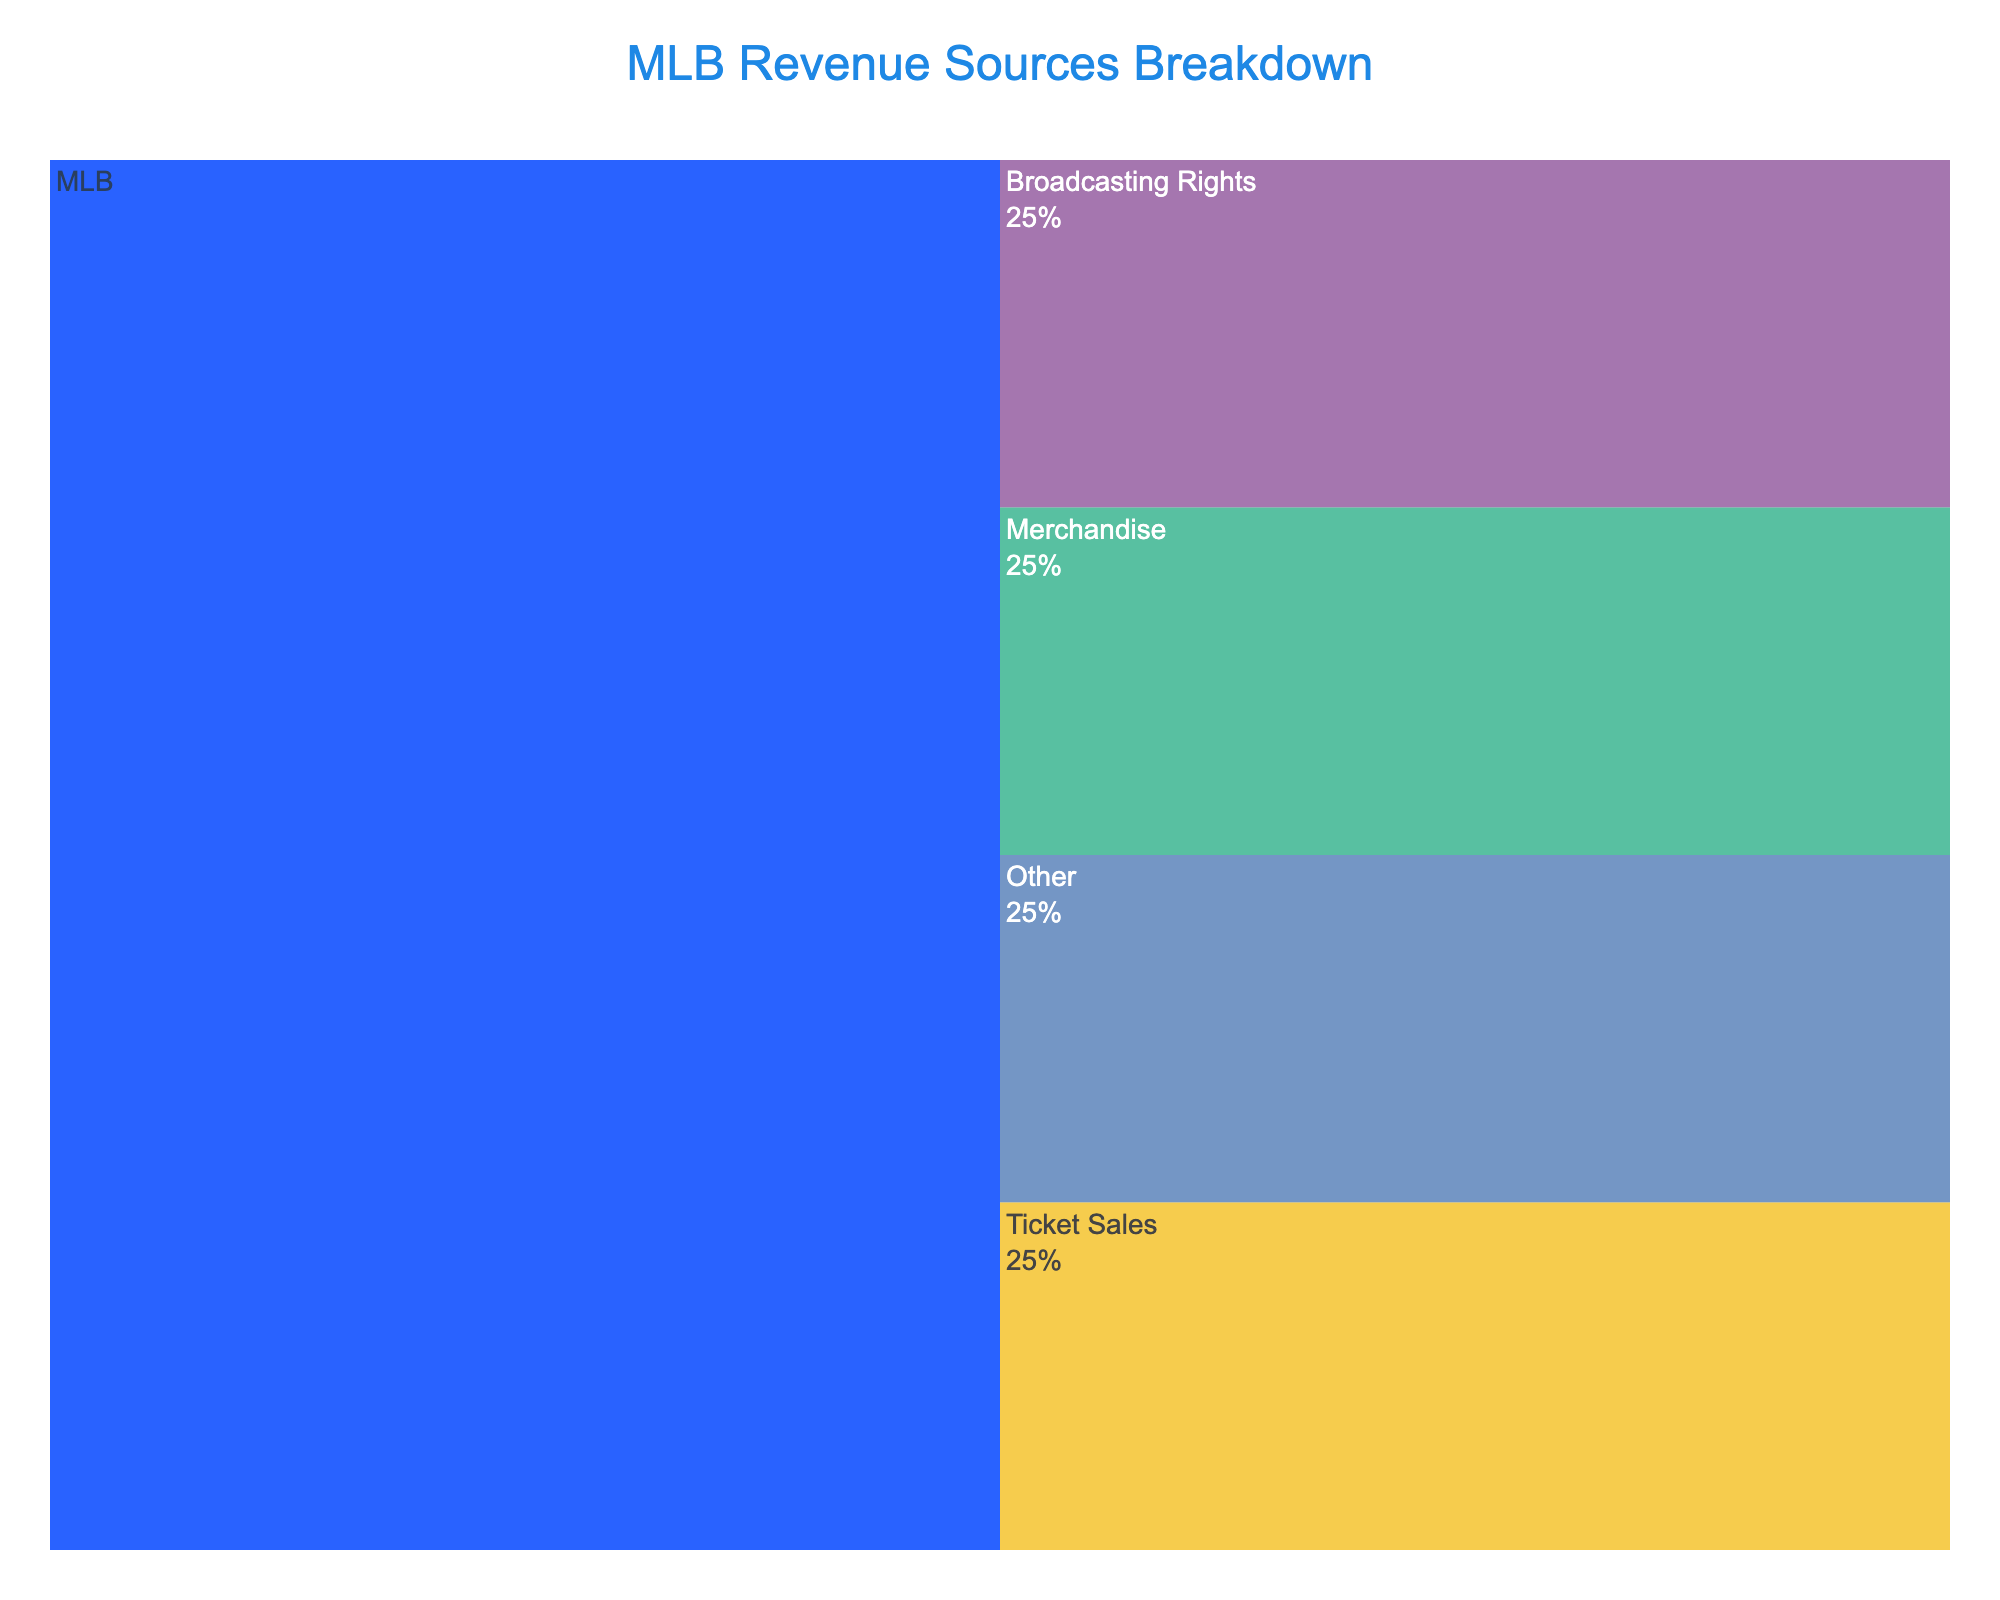What is the title of the Icicle Chart? The title is located at the top of the figure and provides a concise summary of the chart's content. "MLB Revenue Sources Breakdown" is clearly displayed in the title section.
Answer: MLB Revenue Sources Breakdown Which color is used for the root (MLB) level in the chart? The root color is prominently displayed and differentiates the main level from the subordinate ones. The root level (MLB) is shown in a distinct dark blue color.
Answer: Dark blue How many revenue sources are displayed in the chart? The chart breaks down MLB revenue into its components, each represented by a segment. By visually counting these segments at the "Revenue Sources" level, you can determine the total number of revenue sources.
Answer: 4 What percentage of the parent category does "Ticket Sales" represent? The chart includes percentage labels for each segment relative to their parent category. "Ticket Sales" visibly occupies 25% of the parent category (MLB).
Answer: 25% Which revenue source has the smallest representation in the chart? By comparing the relative sizes of all segments under "Revenue Sources," the smallest segment can be identified. The segment labeled "Other" is the smallest.
Answer: Other What are the four revenue sources of MLB depicted in the chart? The chart displays four segments under "Revenue Sources," each labeled accordingly. They are "Ticket Sales," "Merchandise," "Broadcasting Rights," and "Other."
Answer: Ticket Sales, Merchandise, Broadcasting Rights, Other Compare the sizes of "Merchandise" and "Broadcasting Rights." Which is larger? By directly comparing the visual sizes of the "Merchandise" and "Broadcasting Rights" segments, the segment representing "Broadcasting Rights" appears larger.
Answer: Broadcasting Rights If you combined the proportions of "Merchandise" and "Other," what is the total percentage they represent together? "Merchandise" represents 25% and "Other" represents 25%. Adding these percentages together (25% + 25%) gives the combined total.
Answer: 50% What information appears when you hover over a segment? Hovering over each segment reveals a tooltip containing additional information, including the segment's name and its percentage of the parent category. The hover template displays the label of the segment and its percentage of the parent category.
Answer: Label and percentage What font family is used in the chart's layout? The chart layout specifications include information about font settings. The "Arial" font family is used throughout the chart for consistency and readability.
Answer: Arial 